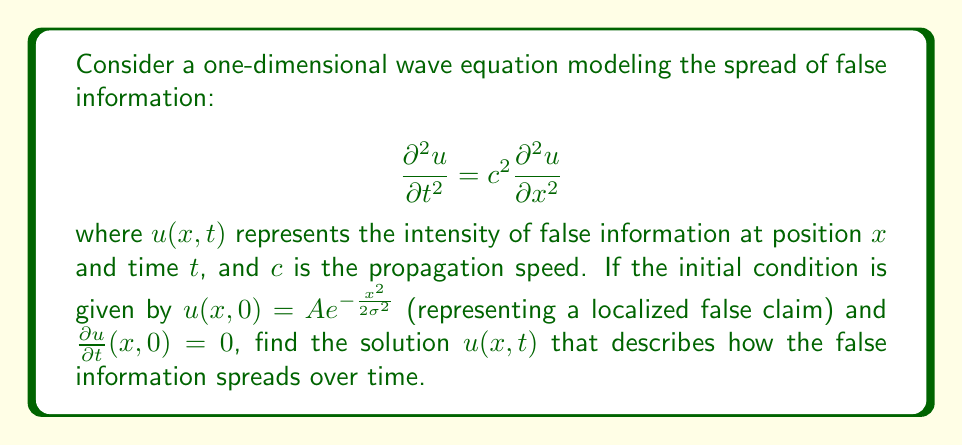Could you help me with this problem? To solve this wave equation with the given initial conditions, we'll follow these steps:

1) The general solution to the 1D wave equation is given by d'Alembert's formula:

   $$u(x,t) = \frac{1}{2}[f(x+ct) + f(x-ct)] + \frac{1}{2c}\int_{x-ct}^{x+ct} g(s) ds$$

   where $f(x)$ is the initial displacement and $g(x)$ is the initial velocity.

2) In our case, $f(x) = Ae^{-\frac{x^2}{2\sigma^2}}$ and $g(x) = 0$.

3) Substituting these into d'Alembert's formula:

   $$u(x,t) = \frac{1}{2}[Ae^{-\frac{(x+ct)^2}{2\sigma^2}} + Ae^{-\frac{(x-ct)^2}{2\sigma^2}}]$$

4) This can be simplified to:

   $$u(x,t) = \frac{A}{2}[e^{-\frac{(x+ct)^2}{2\sigma^2}} + e^{-\frac{(x-ct)^2}{2\sigma^2}}]$$

This solution represents two Gaussian pulses moving in opposite directions at speed $c$, which together describe how the false information spreads over time.
Answer: $u(x,t) = \frac{A}{2}[e^{-\frac{(x+ct)^2}{2\sigma^2}} + e^{-\frac{(x-ct)^2}{2\sigma^2}}]$ 